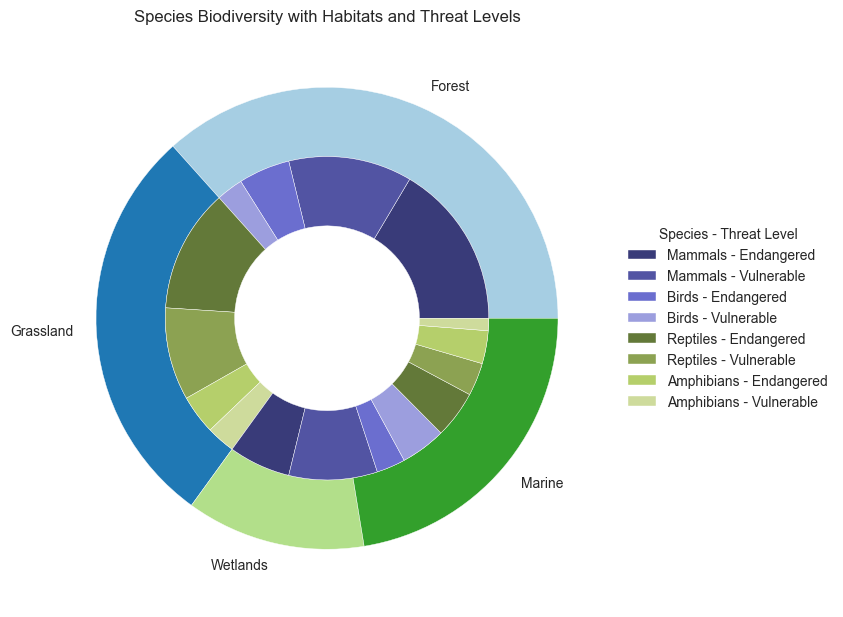What habitat has the highest number of species? By looking at the outer labels of the pie chart, we can see which habitat has the largest segment. The Forest habitat appears to have the largest share compared to Grassland, Wetlands, and Marine.
Answer: Forest What is the total number of endangered species in Marine habitats? To find this, sum the counts of endangered species for all species within the Marine habitat. These are Mammals (8), Birds (6), Reptiles (7), and Amphibians (2). The sum is 8 + 6 + 7 + 2 = 23.
Answer: 23 Which species in the Grassland habitat represents a higher threat level, birds or mammals? By comparing segments within the Grassland habitat's inner ring, we see that both Birds and Mammals have both Endangered and Vulnerable levels. The combined count for Birds (15 + 30 = 45) is higher than for Mammals (25 + 35 = 60). Thus, mammals are at a higher threat level.
Answer: Mammals Between Forest and Wetlands, which habitat has more vulnerable reptiles? By looking at the inner ring segments under Forest and Wetlands for reptiles, we find Forest has 15 vulnerable reptiles, while Wetlands has 9 vulnerable reptiles. Therefore, Forest has more vulnerable reptiles.
Answer: Forest What is the proportion of endangered birds in Wetlands compared to the total number of endangered birds across all habitats? First, find the number of endangered birds in Wetlands (18). Sum the numbers of endangered birds across all habitats: Forest (20), Grassland (15), Wetlands (18), and Marine (6). The total is 20 + 15 + 18 + 6 = 59. The proportion is 18 / 59.
Answer: 18/59 Which habitat has the smallest number of amphibian species in the endangered category? By examining the inner ring for amphibians in the endangered category across all habitats, we see that Marine has the smallest segment with only 2 endangered amphibians compared to Forest (5), Grassland (5), and Wetlands (10).
Answer: Marine How do the total counts of threatened species in the Wetlands compare to the total in Grasslands? Calculate the total counts of endangered and vulnerable species for both habitats. For Wetlands: 10 (Mammals) + 20 + 18 (Birds) + 25 + 5 (Reptiles) + 9 + 10 (Amphibians) + 12 = 109. For Grasslands: 25 (Mammals) + 35 + 15 (Birds) + 30 + 7 (Reptiles) + 12 + 5 (Amphibians) + 9 = 138. Thus, Grasslands have more threatened species.
Answer: Grasslands 